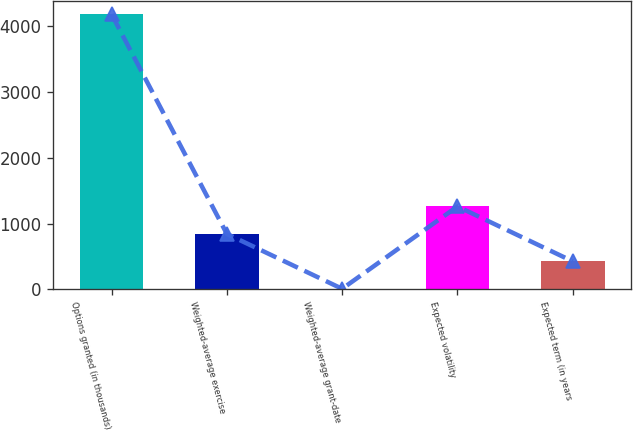<chart> <loc_0><loc_0><loc_500><loc_500><bar_chart><fcel>Options granted (in thousands)<fcel>Weighted-average exercise<fcel>Weighted-average grant-date<fcel>Expected volatility<fcel>Expected term (in years<nl><fcel>4186<fcel>841.68<fcel>5.6<fcel>1259.72<fcel>423.64<nl></chart> 